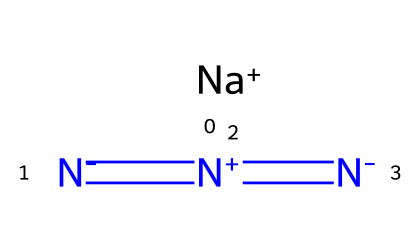What is the total number of atoms in sodium azide? In the structure of sodium azide, there are four atoms in total: one sodium atom and three nitrogen atoms. This can be counted directly from the provided SMILES representation.
Answer: four How many nitrogen atoms are present in sodium azide? The SMILES representation shows three nitrogen atoms, indicated by the three nitrogen symbols 'N'. Therefore, the total count of nitrogen atoms is three.
Answer: three What type of bonding is observed between the nitrogen atoms in sodium azide? The SMILES notation indicates double and single bonds between nitrogen atoms. The '=' sign represents double bonds, and the '-' indicates single bonds, showing that nitrogen atoms are interconnected through both types of bonding.
Answer: double and single What charge does the sodium ion carry in sodium azide? From the SMILES structure, it is clear that the sodium atom is represented with a '+' sign, denoting it as a positively charged ion.
Answer: positive What is the significance of sodium azide's structure in airbag deployment? Sodium azide decomposes explosively into nitrogen gas and sodium when heated, providing an effective gas source for rapid airbag inflation when triggered by an impact, which is indicated by the chemical stability of the azide structure.
Answer: rapid inflation Is sodium azide an organic or inorganic compound? Sodium azide consists solely of inorganic components (sodium and nitrogen) based on its structural composition; thus, it is classified as an inorganic compound.
Answer: inorganic 